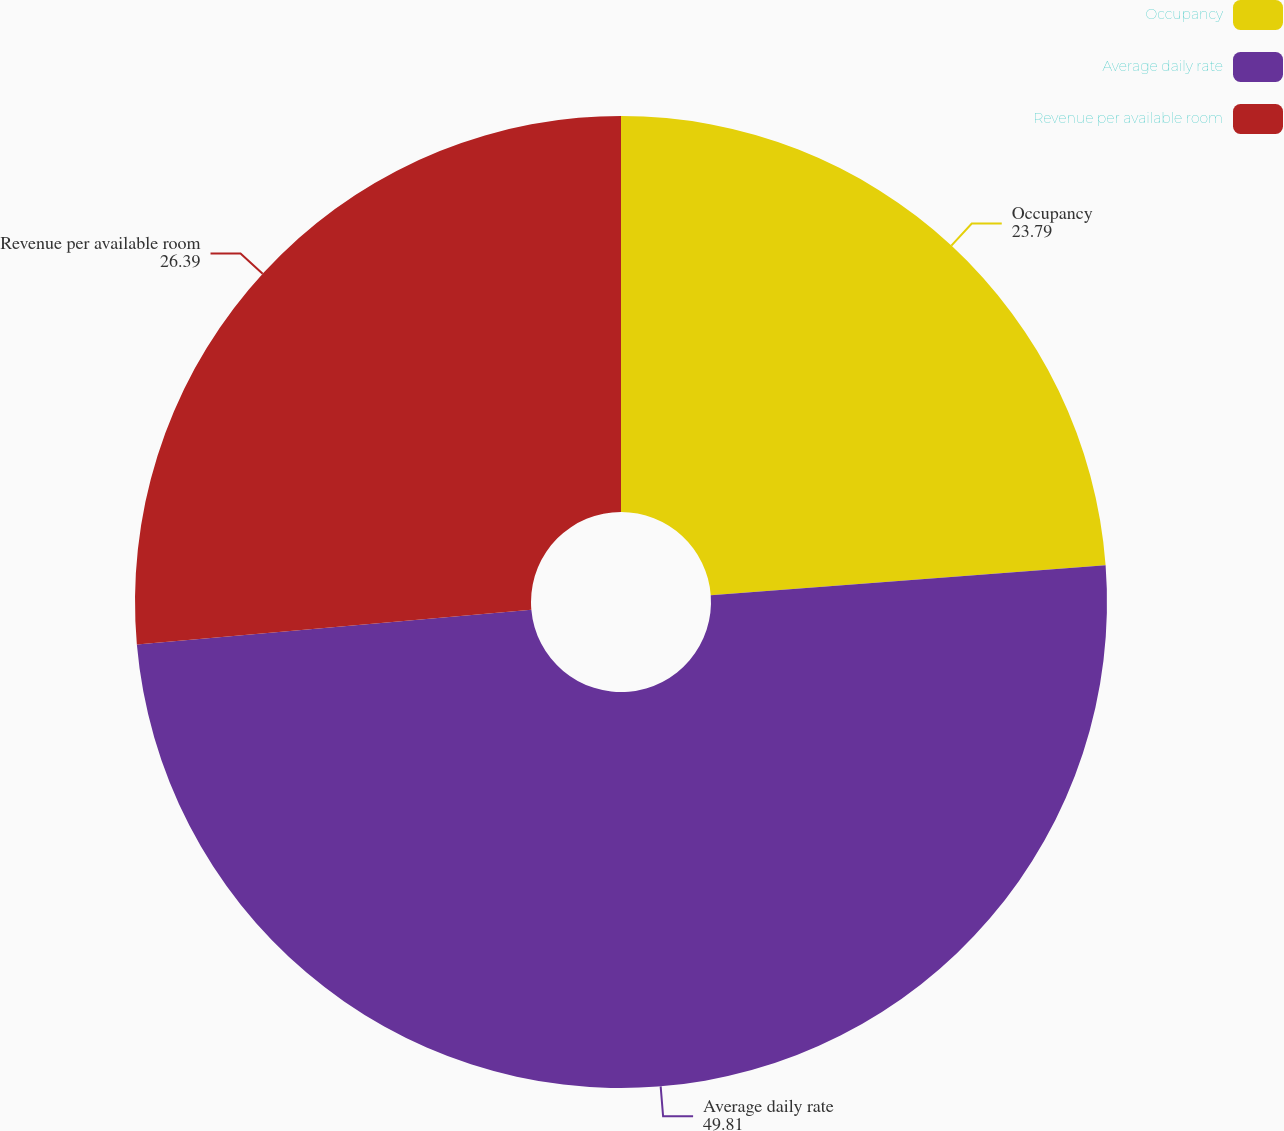Convert chart to OTSL. <chart><loc_0><loc_0><loc_500><loc_500><pie_chart><fcel>Occupancy<fcel>Average daily rate<fcel>Revenue per available room<nl><fcel>23.79%<fcel>49.81%<fcel>26.39%<nl></chart> 